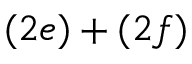Convert formula to latex. <formula><loc_0><loc_0><loc_500><loc_500>( 2 e ) + ( 2 f )</formula> 